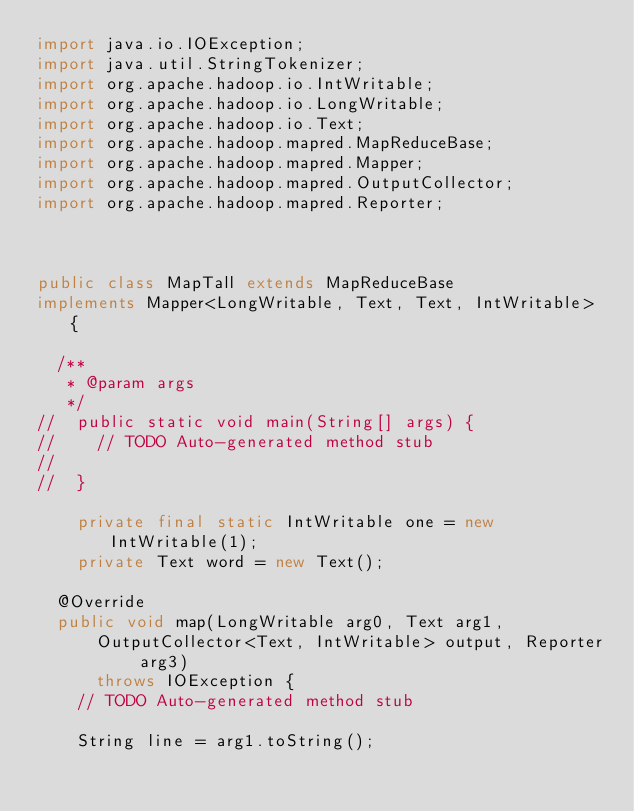<code> <loc_0><loc_0><loc_500><loc_500><_Java_>import java.io.IOException;
import java.util.StringTokenizer;
import org.apache.hadoop.io.IntWritable;
import org.apache.hadoop.io.LongWritable;
import org.apache.hadoop.io.Text;
import org.apache.hadoop.mapred.MapReduceBase;
import org.apache.hadoop.mapred.Mapper;
import org.apache.hadoop.mapred.OutputCollector;
import org.apache.hadoop.mapred.Reporter;



public class MapTall extends MapReduceBase
implements Mapper<LongWritable, Text, Text, IntWritable> {

	/**
	 * @param args
	 */
//	public static void main(String[] args) {
//		// TODO Auto-generated method stub
//
//	}
	
    private final static IntWritable one = new IntWritable(1); 
    private Text word = new Text(); 

	@Override
	public void map(LongWritable arg0, Text arg1,
			OutputCollector<Text, IntWritable> output, Reporter arg3)
			throws IOException {
		// TODO Auto-generated method stub
		
		String line = arg1.toString();</code> 